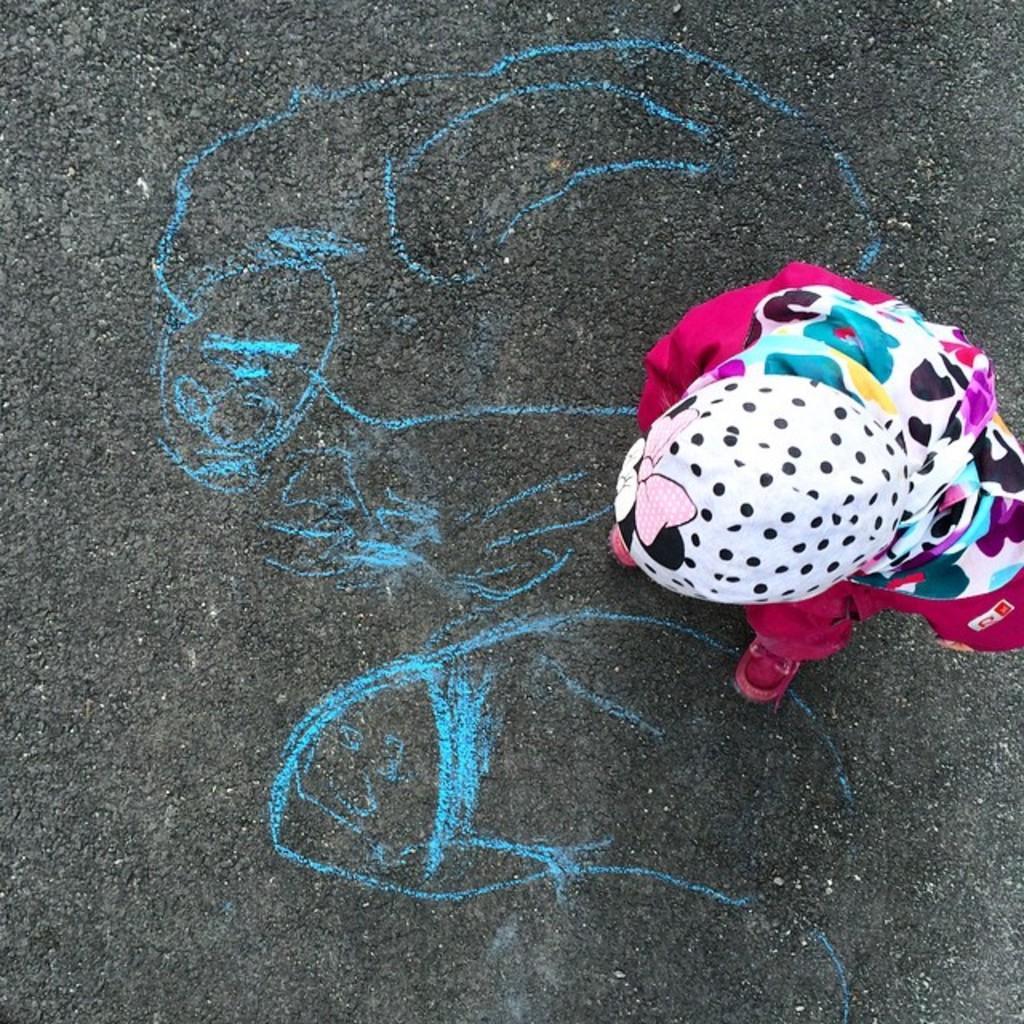Can you describe this image briefly? In this image there is a person standing on the road. In front of him there is a drawing on the road. 